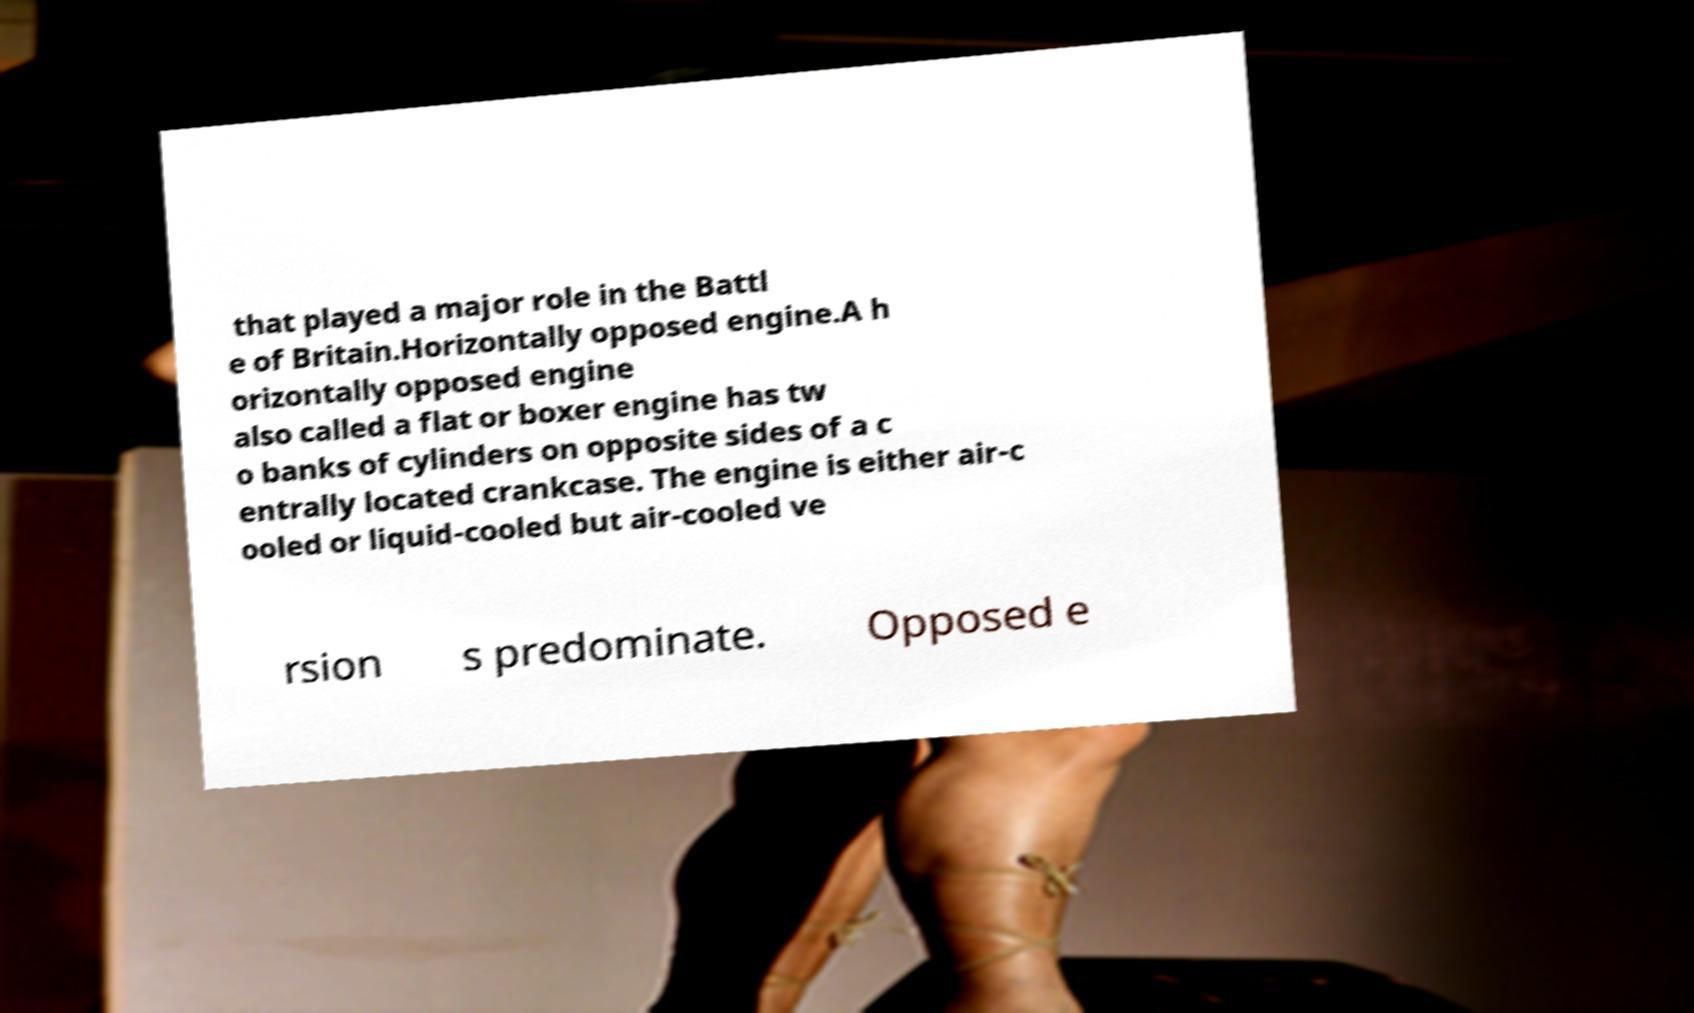Could you assist in decoding the text presented in this image and type it out clearly? that played a major role in the Battl e of Britain.Horizontally opposed engine.A h orizontally opposed engine also called a flat or boxer engine has tw o banks of cylinders on opposite sides of a c entrally located crankcase. The engine is either air-c ooled or liquid-cooled but air-cooled ve rsion s predominate. Opposed e 